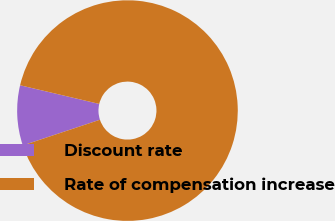Convert chart to OTSL. <chart><loc_0><loc_0><loc_500><loc_500><pie_chart><fcel>Discount rate<fcel>Rate of compensation increase<nl><fcel>8.8%<fcel>91.2%<nl></chart> 